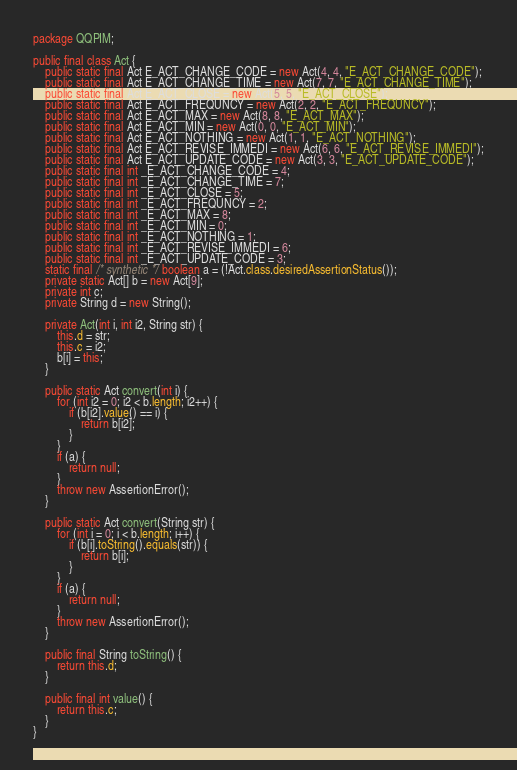<code> <loc_0><loc_0><loc_500><loc_500><_Java_>package QQPIM;

public final class Act {
    public static final Act E_ACT_CHANGE_CODE = new Act(4, 4, "E_ACT_CHANGE_CODE");
    public static final Act E_ACT_CHANGE_TIME = new Act(7, 7, "E_ACT_CHANGE_TIME");
    public static final Act E_ACT_CLOSE = new Act(5, 5, "E_ACT_CLOSE");
    public static final Act E_ACT_FREQUNCY = new Act(2, 2, "E_ACT_FREQUNCY");
    public static final Act E_ACT_MAX = new Act(8, 8, "E_ACT_MAX");
    public static final Act E_ACT_MIN = new Act(0, 0, "E_ACT_MIN");
    public static final Act E_ACT_NOTHING = new Act(1, 1, "E_ACT_NOTHING");
    public static final Act E_ACT_REVISE_IMMEDI = new Act(6, 6, "E_ACT_REVISE_IMMEDI");
    public static final Act E_ACT_UPDATE_CODE = new Act(3, 3, "E_ACT_UPDATE_CODE");
    public static final int _E_ACT_CHANGE_CODE = 4;
    public static final int _E_ACT_CHANGE_TIME = 7;
    public static final int _E_ACT_CLOSE = 5;
    public static final int _E_ACT_FREQUNCY = 2;
    public static final int _E_ACT_MAX = 8;
    public static final int _E_ACT_MIN = 0;
    public static final int _E_ACT_NOTHING = 1;
    public static final int _E_ACT_REVISE_IMMEDI = 6;
    public static final int _E_ACT_UPDATE_CODE = 3;
    static final /* synthetic */ boolean a = (!Act.class.desiredAssertionStatus());
    private static Act[] b = new Act[9];
    private int c;
    private String d = new String();

    private Act(int i, int i2, String str) {
        this.d = str;
        this.c = i2;
        b[i] = this;
    }

    public static Act convert(int i) {
        for (int i2 = 0; i2 < b.length; i2++) {
            if (b[i2].value() == i) {
                return b[i2];
            }
        }
        if (a) {
            return null;
        }
        throw new AssertionError();
    }

    public static Act convert(String str) {
        for (int i = 0; i < b.length; i++) {
            if (b[i].toString().equals(str)) {
                return b[i];
            }
        }
        if (a) {
            return null;
        }
        throw new AssertionError();
    }

    public final String toString() {
        return this.d;
    }

    public final int value() {
        return this.c;
    }
}
</code> 